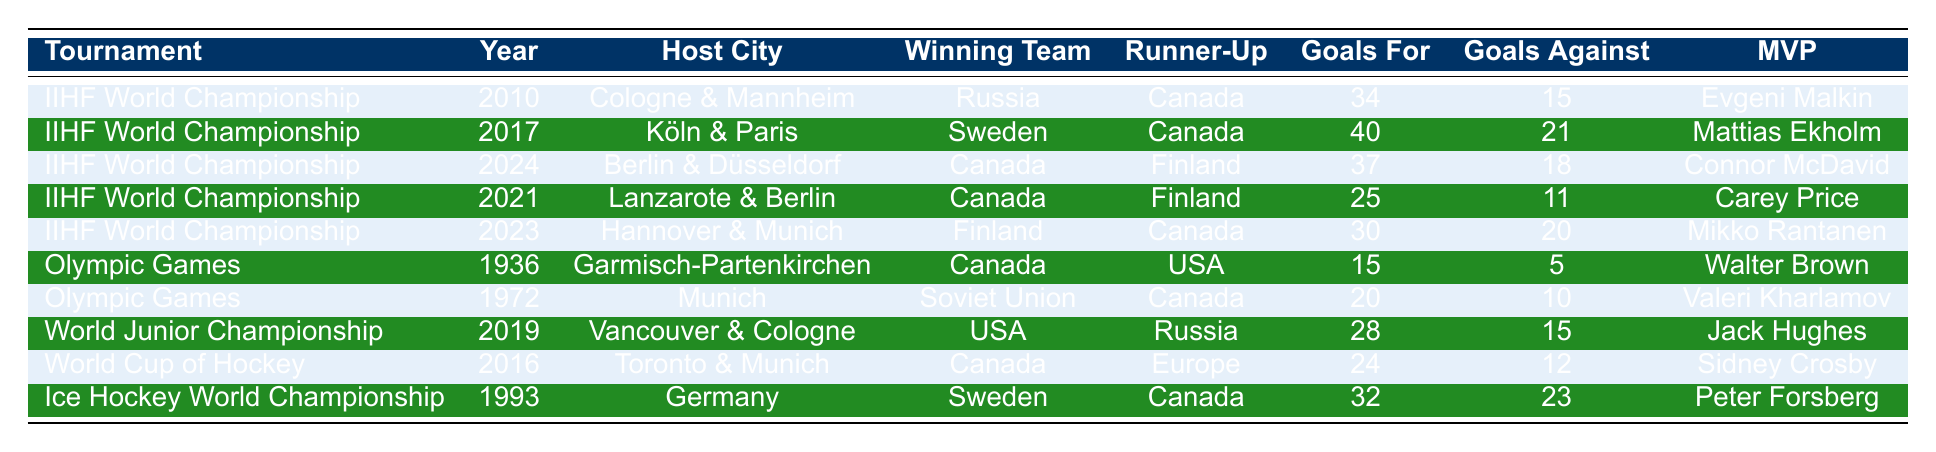What year did Canada last win the IIHF World Championship hosted in Germany? Canada won the IIHF World Championship in 2024, which is the only instance listed in the table for that tournament held in Germany.
Answer: 2024 Which team scored the most goals in a tournament hosted in Germany according to the table? In the IIHF World Championship 2017, Sweden scored 40 goals, which is the highest number of goals for any tournament hosted in Germany listed in the table.
Answer: Sweden What is the total number of goals scored by Canada across all tournaments listed in the table? Adding the goals scored by Canada: 34 (2010) + 40 (2017) + 37 (2024) + 25 (2021) + 30 (2023) + 15 (1936) + 20 (1972) + 24 (2016) + 32 (1993) = 307.
Answer: 307 Did Canada ever finish as the runner-up in the Olympic Games hosted in Germany? Yes, Canada finished as the runner-up to the Soviet Union in the 1972 Olympic Games hosted in Munich.
Answer: Yes Which MVP was awarded in the tournament that Canada won hosted in Germany? The only tournament listed where Canada won and was hosted in Germany is the IIHF World Championship 2024, where Connor McDavid was awarded the MVP.
Answer: Connor McDavid What is the difference in goals scored between Canada and Finland in the 2024 IIHF World Championship? Canada scored 37 goals, and Finland scored 18 goals in the 2024 tournament. The difference is 37 - 18 = 19.
Answer: 19 Which teams were the runner-up in the Olympic Games hosted in Germany? In the 1936 Olympics, the runner-up was the USA, and in 1972, it was Canada. Both tournaments hosted in Germany had different runner-up teams.
Answer: USA and Canada What was the winning team's goals against in the 2023 IIHF World Championship? In the 2023 IIHF World Championship, Finland, which was the winning team, had 20 goals against.
Answer: 20 In which tournament and year did Canada first win the Olympic gold in Germany? Canada first won the Olympic gold in 1936 during the Olympic Games held in Garmisch-Partenkirchen.
Answer: 1936 Olympic Games Which tournament hosted in Germany had less than 30 goals scored by the winning team according to the table? The IIHF World Championship 2021 had 25 goals scored by Canada, which is less than 30 goals.
Answer: IIHF World Championship 2021 